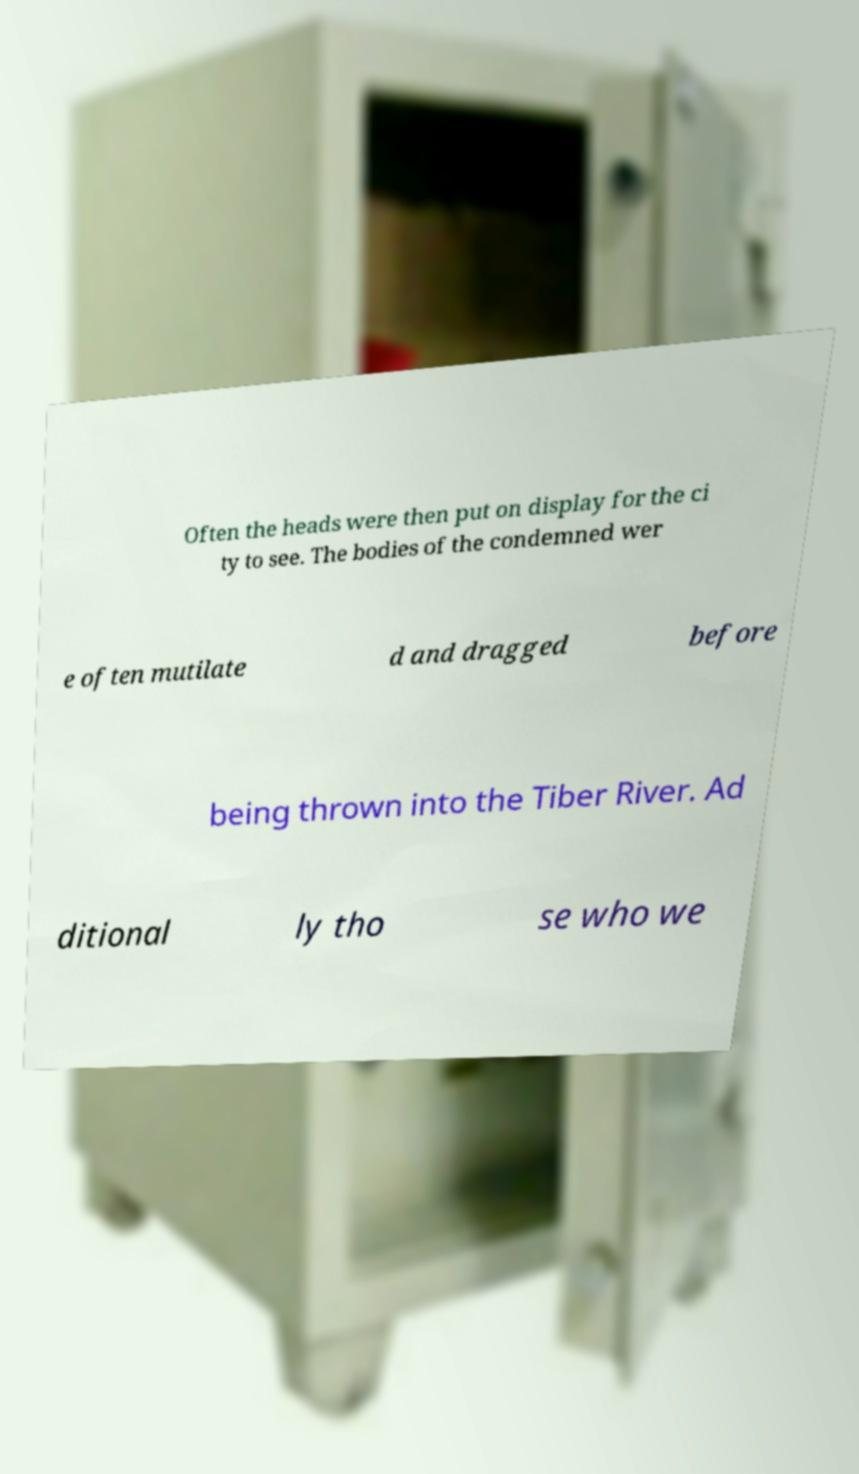What messages or text are displayed in this image? I need them in a readable, typed format. Often the heads were then put on display for the ci ty to see. The bodies of the condemned wer e often mutilate d and dragged before being thrown into the Tiber River. Ad ditional ly tho se who we 